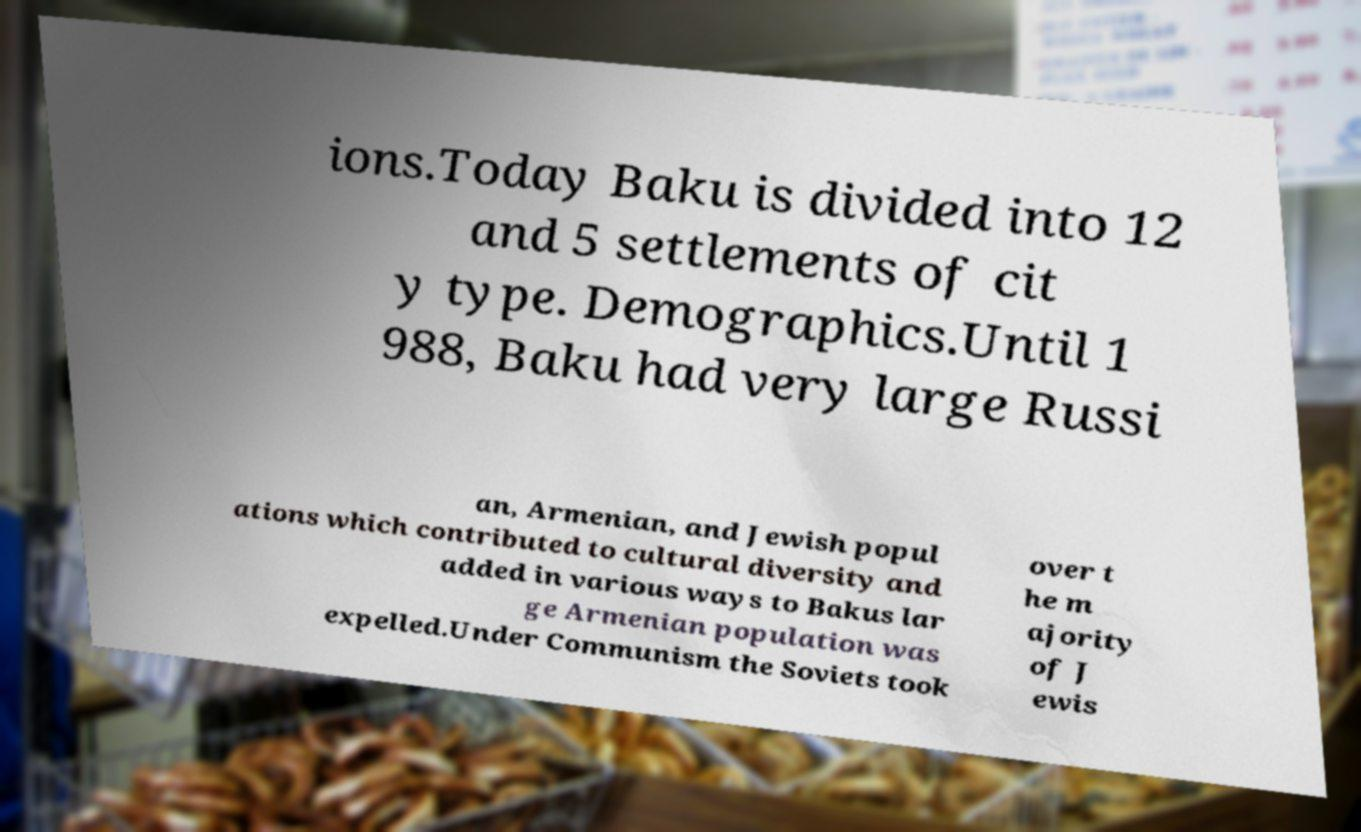Could you extract and type out the text from this image? ions.Today Baku is divided into 12 and 5 settlements of cit y type. Demographics.Until 1 988, Baku had very large Russi an, Armenian, and Jewish popul ations which contributed to cultural diversity and added in various ways to Bakus lar ge Armenian population was expelled.Under Communism the Soviets took over t he m ajority of J ewis 